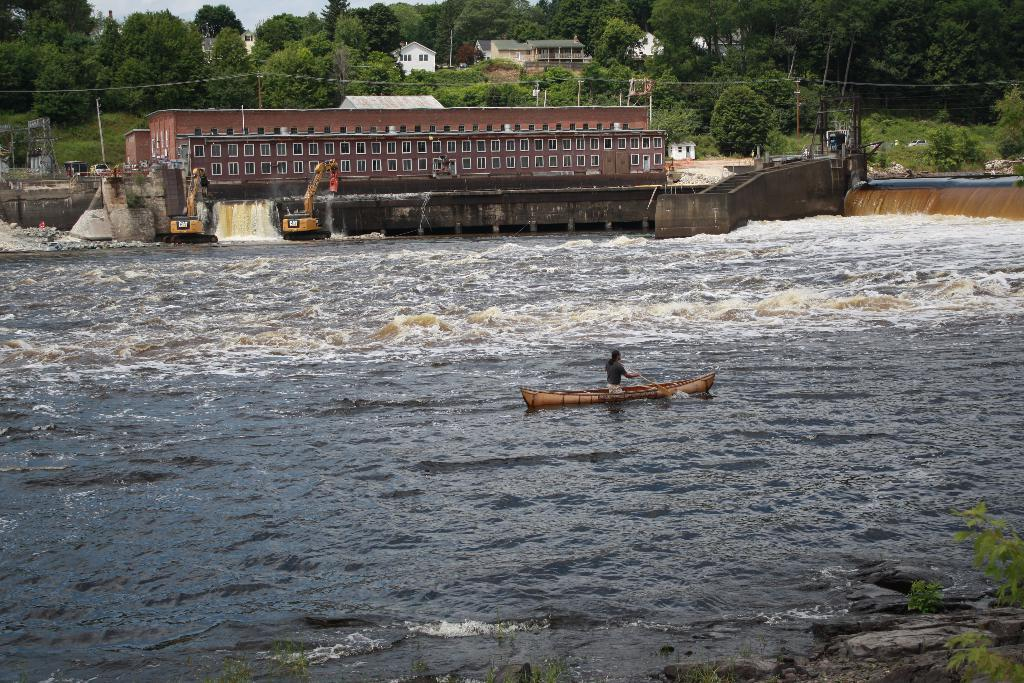What type of structures can be seen in the image? There are buildings in the image. What other natural elements are present in the image? There are trees in the image. Are there any construction vehicles or equipment visible? Yes, there are cranes in the image. What is located on the water in the image? There is a boat in the water. Who is in the boat? There is a man in the boat. How would you describe the weather based on the image? The sky is cloudy in the image. What type of shoe is the man wearing in the bedroom in the image? There is no bedroom or shoe present in the image. How many sons does the man in the boat have in the image? There is no information about the man's sons in the image. 